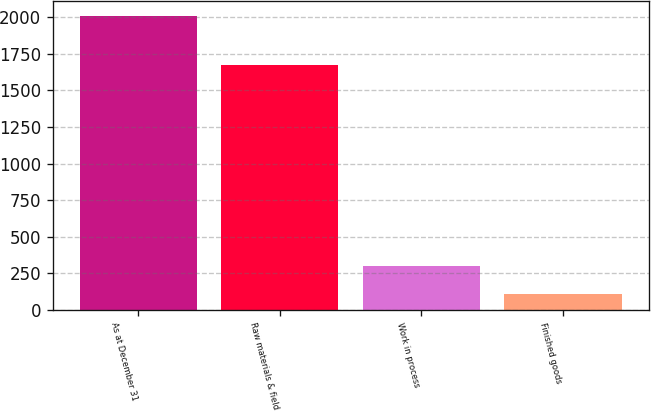Convert chart. <chart><loc_0><loc_0><loc_500><loc_500><bar_chart><fcel>As at December 31<fcel>Raw materials & field<fcel>Work in process<fcel>Finished goods<nl><fcel>2008<fcel>1674<fcel>298.9<fcel>109<nl></chart> 